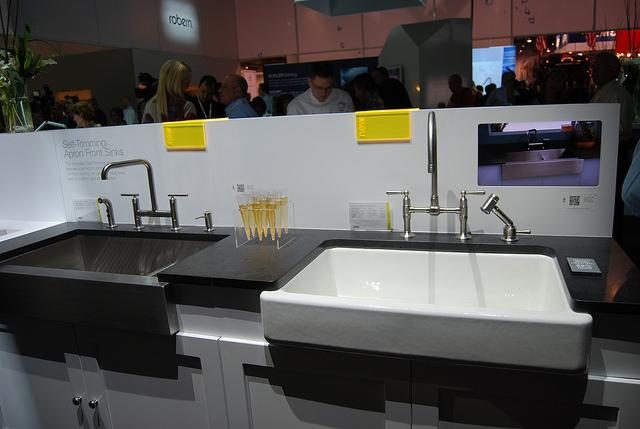What is found in the room?

Choices:
A) car
B) sink
C) hammer
D) snake sink 